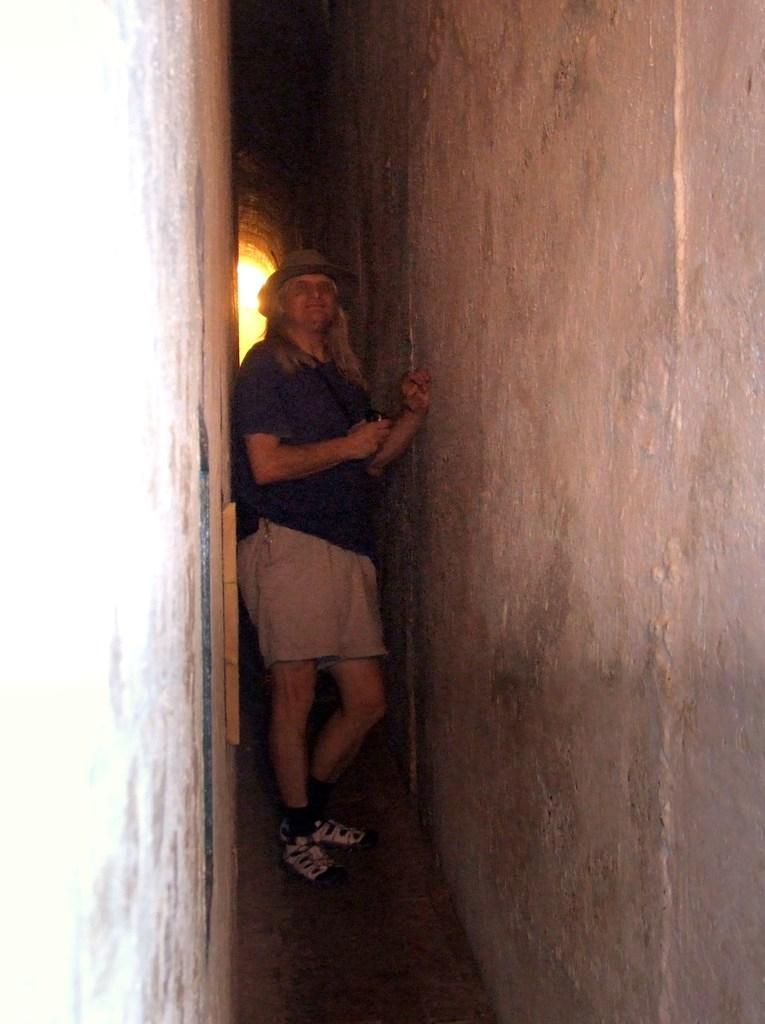What is the main subject of the picture? The main subject of the picture is a man. Can you describe the man's clothing in the image? The man is wearing a hat, spectacles, a t-shirt, shorts, and shoes. Where is the man located in the image? The man is standing between walls in the image. What can be seen in the background of the image? There is a light beam visible in the background. What type of business does the man's mother own in the image? There is no information about the man's mother or any business in the image. Can you tell me how many ears the man has in the image? The image does not show the man's ears, so it cannot be determined from the picture. 